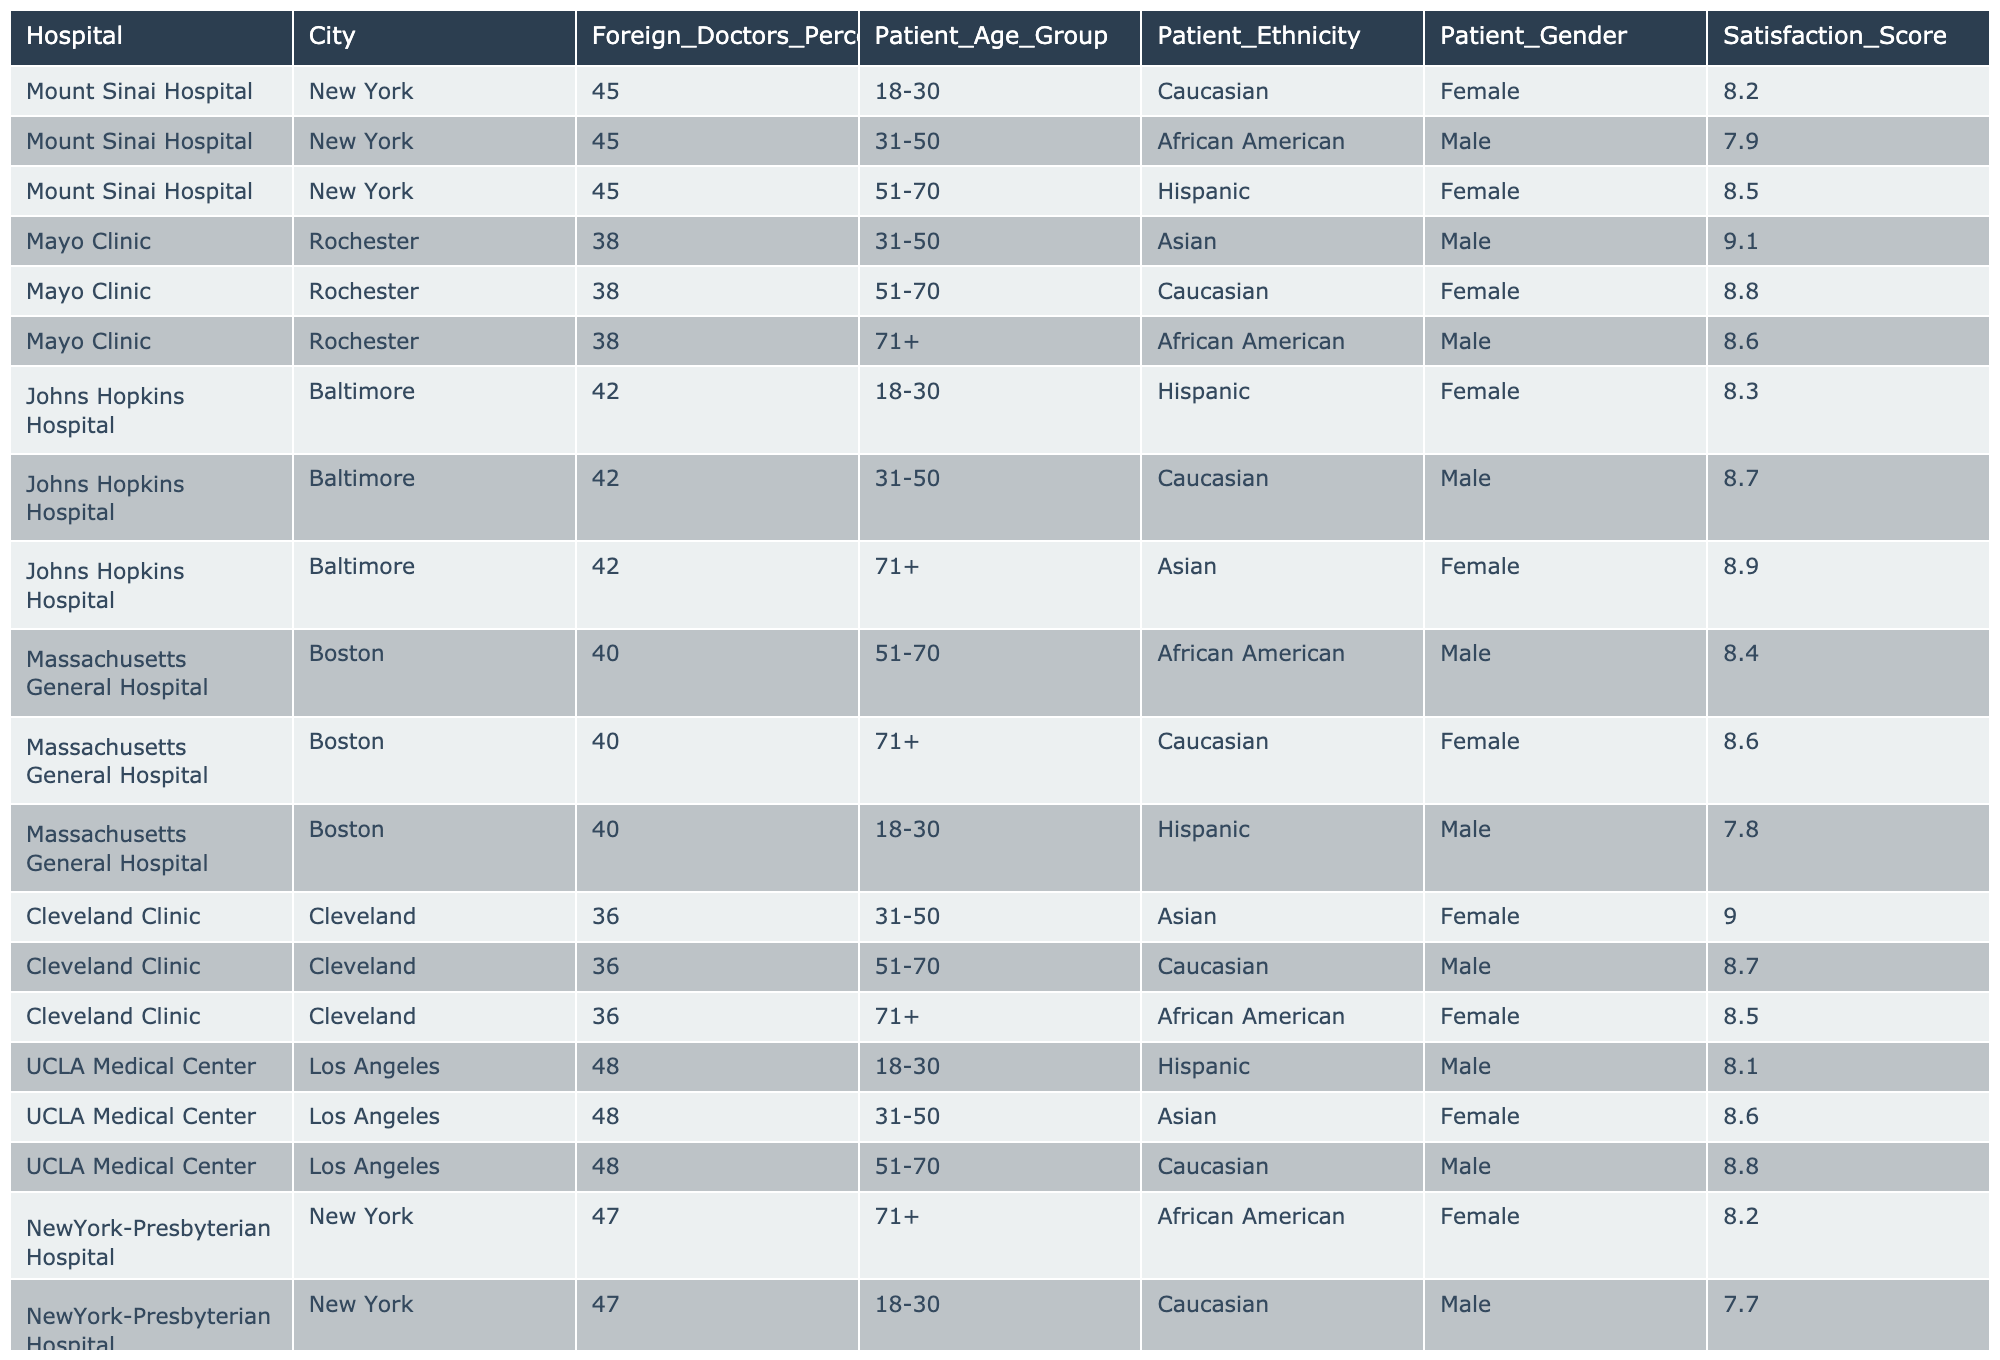What is the highest satisfaction score reported among the hospitals? Searching through the satisfaction scores, the highest value is 9.1 at Mayo Clinic for an Asian male patient aged 31-50.
Answer: 9.1 What percentage of foreign doctors does UCLA Medical Center have? Looking at the table, UCLA Medical Center has 48% of foreign doctors.
Answer: 48% Which hospital has the lowest satisfaction score, and what is that score? The table shows Massachusetts General Hospital has the lowest satisfaction score of 7.8 for a Hispanic male patient aged 18-30.
Answer: 7.8 What is the average satisfaction score for patients of Asian ethnicity across all hospitals? The satisfaction scores for Asian patients are 9.0 (Cleveland Clinic, 31-50), 8.9 (Johns Hopkins, 71+), and 8.6 (UCLA Medical Center, 31-50), totaling to 26.5. Dividing 26.5 by 3 gives an average score of approximately 8.83.
Answer: 8.83 Is there a hospital where all patient satisfaction scores are above 8.0? Evaluating the scores for each hospital, both Mayo Clinic and Johns Hopkins Hospital have all scores above 8.0.
Answer: Yes Which age group shows the highest satisfaction score overall? The satisfaction scores by age group are as follows: 18-30 has scores of 8.2, 8.1, and 7.7; 31-50 has scores of 9.1, 8.7, 8.6, and 8.4; 51-70 has scores of 8.5, 8.8, and 8.4; and 71+ has scores of 8.6, 8.5, 8.9, and 8.2. The highest average is for the 31-50 age group at roughly 8.78.
Answer: 31-50 How many hospitals have a higher percentage of foreign doctors than Cleveland Clinic? Cleveland Clinic has 36% foreign doctors. Comparing this percentage, Mount Sinai Hospital (45%), Mayo Clinic (38%), Johns Hopkins Hospital (42%), and UCLA Medical Center (48%) have higher percentages, totaling 4 hospitals.
Answer: 4 What is the satisfaction score for male patients aged 51-70 at Massachusetts General Hospital? Checking the table reveals that the satisfaction score for male patients aged 51-70 at Massachusetts General Hospital is 8.4.
Answer: 8.4 What proportion of the total patients in the table are from the 71+ age group? The table shows 4 patients (one from each of New York-Presbyterian, Johns Hopkins, Cleveland Clinic, and Massachusetts General Hospital) out of 12 total patients. This results in a proportion of 4/12 or 1/3, approximately 33.33%.
Answer: 33.33% Which gender has the highest reported patient satisfaction scores overall? Analyzing the male scores (7.9, 9.1, 8.7, 8.4, 8.8, 7.8), total is 51.3, average 8.55, while female scores (8.2, 8.5, 8.3, 8.8, 8.9, 8.6) total to 51.3 and average to 8.55 as well. Both genders have equal average satisfaction scores.
Answer: Equal How does the satisfaction score of patients aged 18-30 compare with those aged 71+ across all hospitals? The average satisfaction score for 18-30 patients is (8.2 + 8.1 + 7.7) / 3 = 8.0, while for 71+ patients, it is (8.6 + 8.5 + 8.9 + 8.2) / 4 = 8.55. Comparison shows patients aged 71+ have a higher average satisfaction score.
Answer: 71+ patients have a higher satisfaction score 